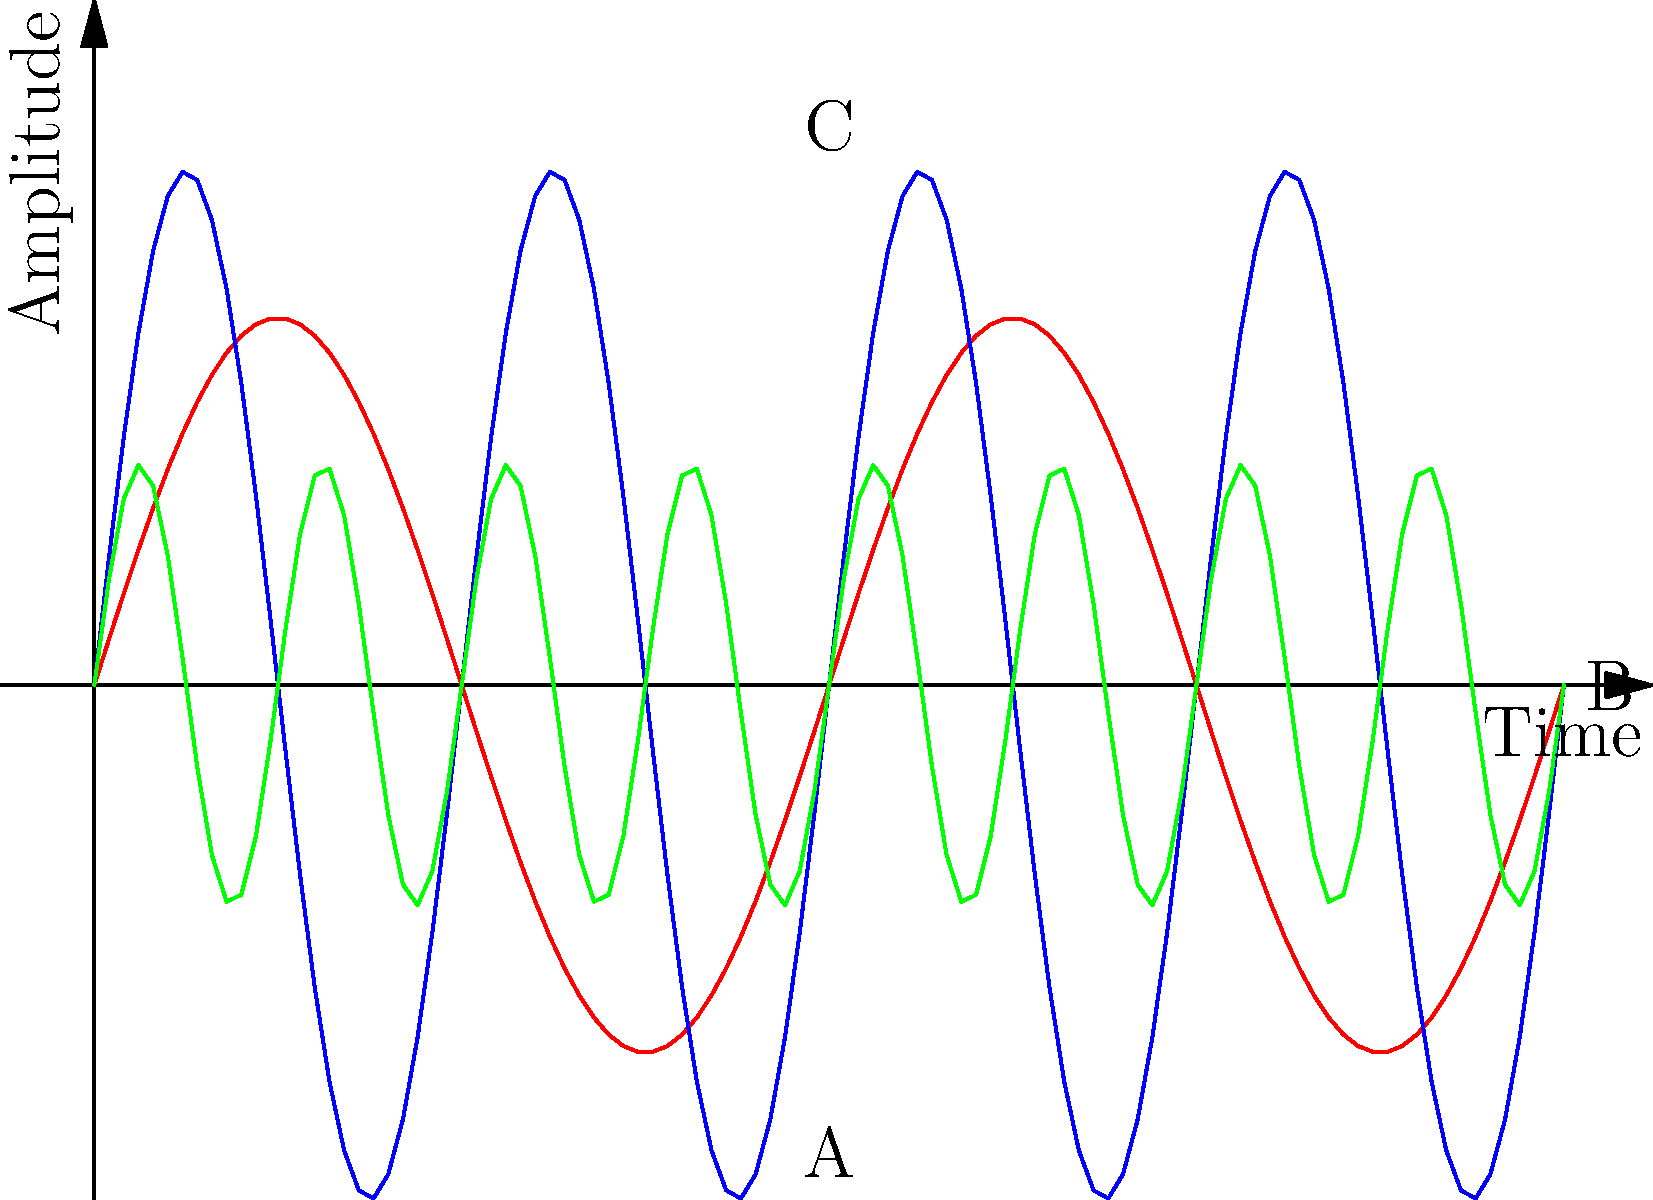Based on your experience as a public safety officer, which waveform pattern (A, B, or C) most likely represents the siren of an ambulance? To identify the correct waveform for an ambulance siren, let's analyze each pattern:

1. Waveform A (red):
   - Low frequency (wider waves)
   - Moderate amplitude
   - Characteristics: Steady, deep tone

2. Waveform B (blue):
   - Medium frequency
   - Highest amplitude
   - Characteristics: Strong, attention-grabbing sound

3. Waveform C (green):
   - High frequency (narrower waves)
   - Lowest amplitude
   - Characteristics: Rapid, high-pitched tone

Ambulance sirens typically have:
- A higher pitch to cut through ambient noise
- Rapid oscillations to create urgency
- Moderate to low amplitude for urban use

Waveform C best matches these characteristics with its high frequency and lower amplitude, making it the most likely representation of an ambulance siren. Waveform A is more typical of a fire truck (deeper tone), while Waveform B could represent a police siren (stronger, more attention-grabbing).
Answer: C 